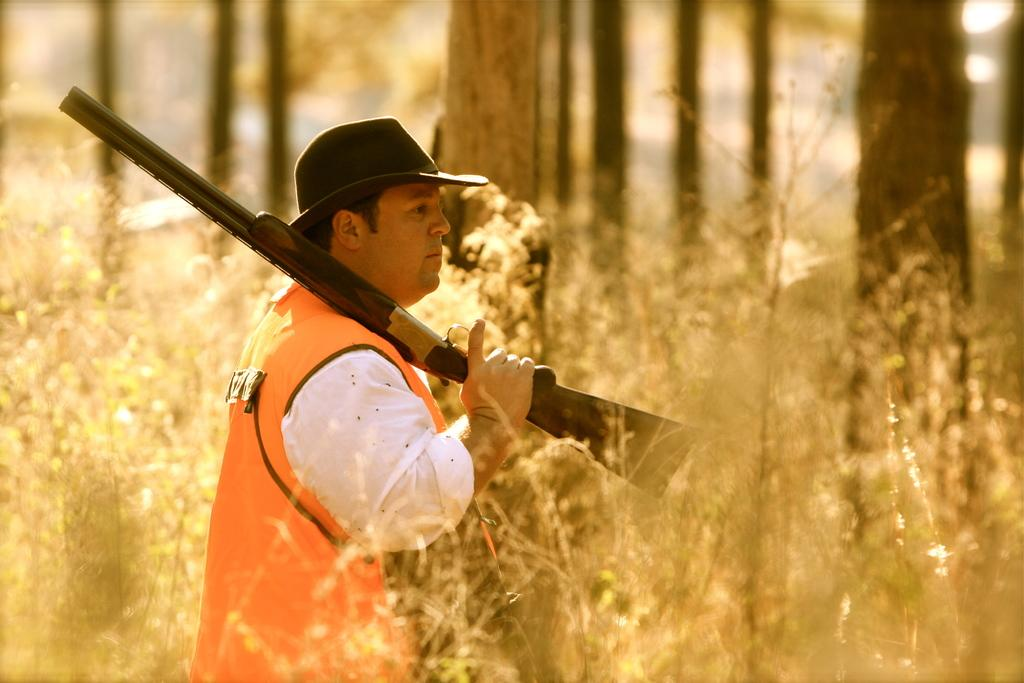Who or what is present in the image? There is a person in the image. What is the person holding? The person is holding a gun. What can be seen between the person and the camera? There are plants in front of the person. What is visible in the distance behind the person? There are trees in the background of the image. What effect does the gun have on the school in the image? There is no school present in the image, so the gun cannot have any effect on it. 